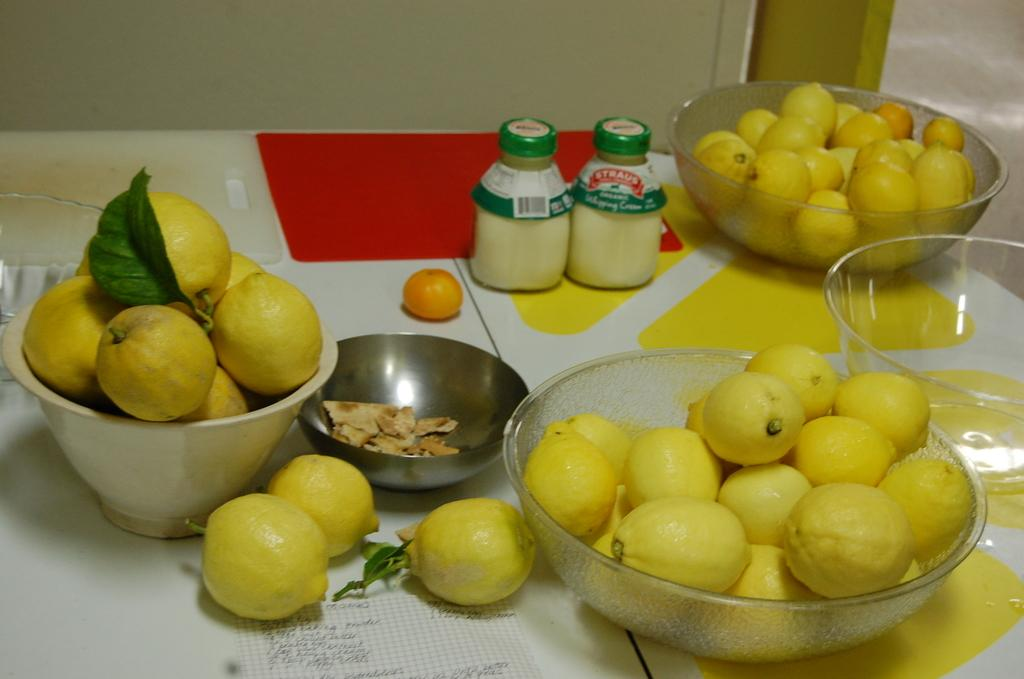What is the main piece of furniture in the image? There is a table in the image. How many bowls are on the table? There are four bowls on the table. What is in each of the bowls? Each bowl contains oranges. What else can be seen on the table besides the bowls? There are two bottles and two cutting plates on the table. What type of string is used to tie the oranges together in the image? There is no string used to tie the oranges together in the image; they are simply placed in the bowls. 